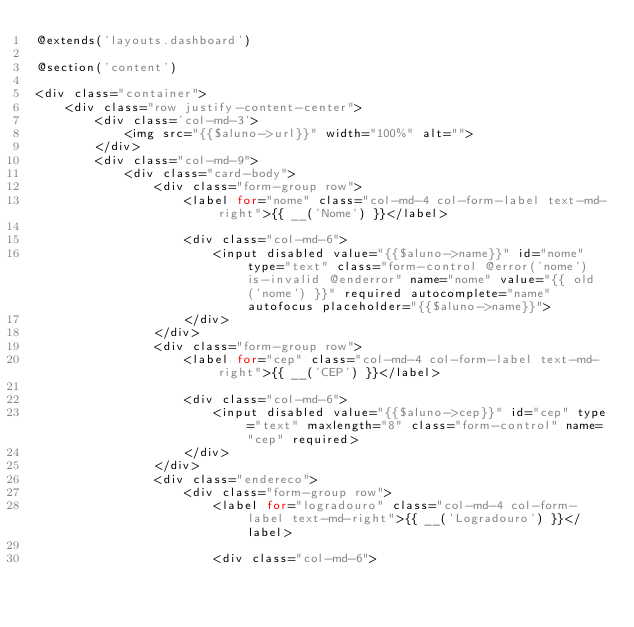<code> <loc_0><loc_0><loc_500><loc_500><_PHP_>@extends('layouts.dashboard')

@section('content')

<div class="container">
    <div class="row justify-content-center">
        <div class='col-md-3'>
            <img src="{{$aluno->url}}" width="100%" alt="">
        </div>
        <div class="col-md-9">
            <div class="card-body">     
                <div class="form-group row">
                    <label for="nome" class="col-md-4 col-form-label text-md-right">{{ __('Nome') }}</label>

                    <div class="col-md-6">
                        <input disabled value="{{$aluno->name}}" id="nome" type="text" class="form-control @error('nome') is-invalid @enderror" name="nome" value="{{ old('nome') }}" required autocomplete="name" autofocus placeholder="{{$aluno->name}}">
                    </div>
                </div>
                <div class="form-group row">
                    <label for="cep" class="col-md-4 col-form-label text-md-right">{{ __('CEP') }}</label>

                    <div class="col-md-6">                                
                        <input disabled value="{{$aluno->cep}}" id="cep" type="text" maxlength="8" class="form-control" name="cep" required>                            
                    </div>
                </div>
                <div class="endereco">
                    <div class="form-group row">
                        <label for="logradouro" class="col-md-4 col-form-label text-md-right">{{ __('Logradouro') }}</label>

                        <div class="col-md-6"></code> 